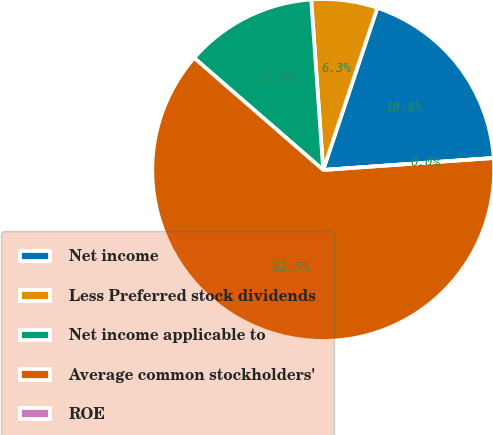Convert chart to OTSL. <chart><loc_0><loc_0><loc_500><loc_500><pie_chart><fcel>Net income<fcel>Less Preferred stock dividends<fcel>Net income applicable to<fcel>Average common stockholders'<fcel>ROE<nl><fcel>18.75%<fcel>6.25%<fcel>12.5%<fcel>62.49%<fcel>0.0%<nl></chart> 